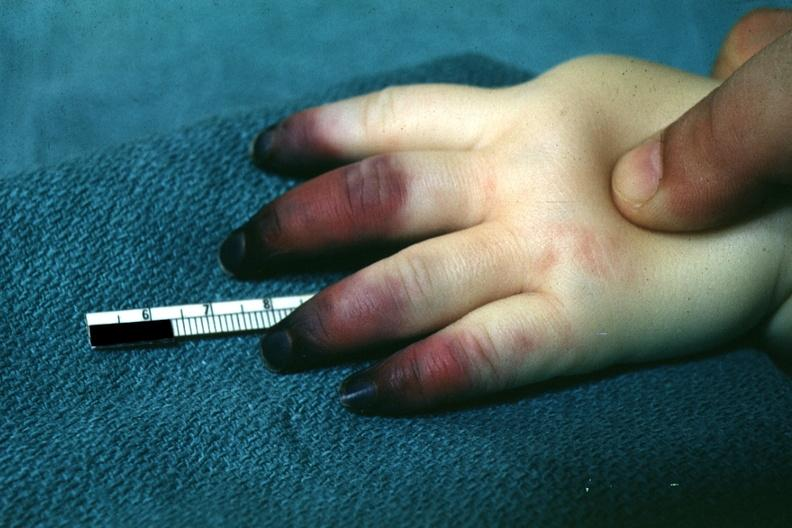how does this image show outstandingly horrible example in infant?
Answer the question using a single word or phrase. With apparent gangrene of distal and middle phalanges pseudomonas sepsis 